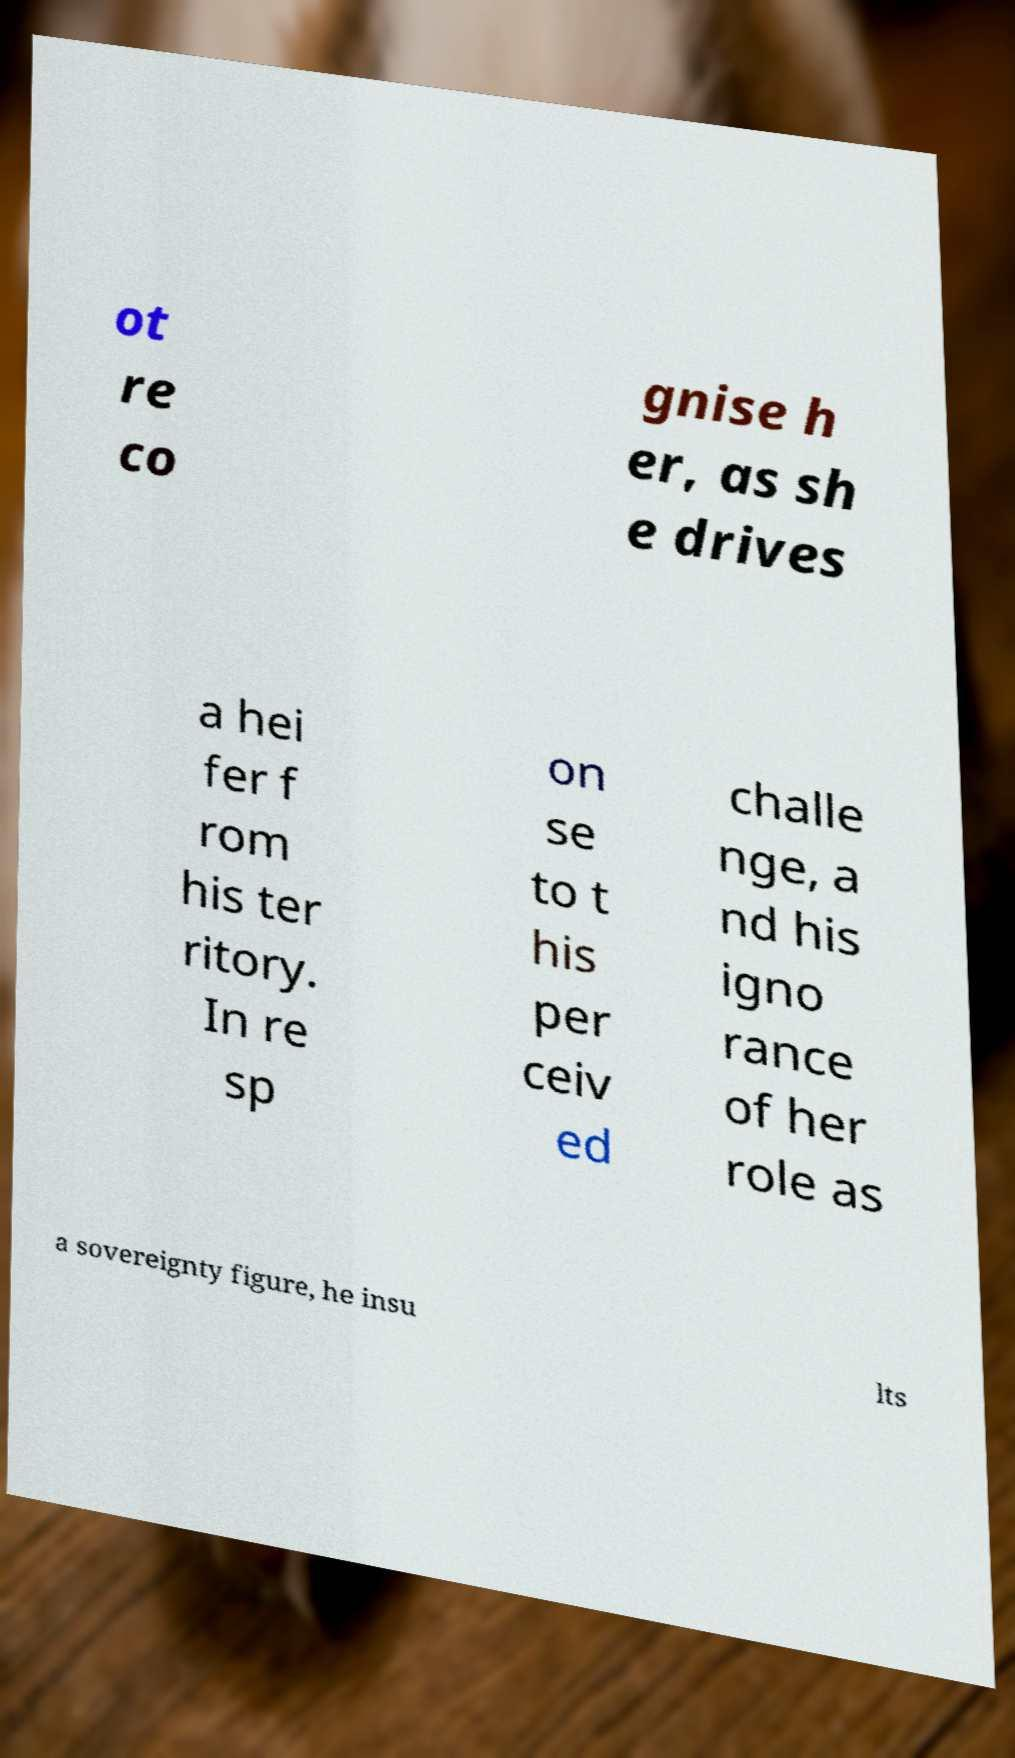For documentation purposes, I need the text within this image transcribed. Could you provide that? ot re co gnise h er, as sh e drives a hei fer f rom his ter ritory. In re sp on se to t his per ceiv ed challe nge, a nd his igno rance of her role as a sovereignty figure, he insu lts 